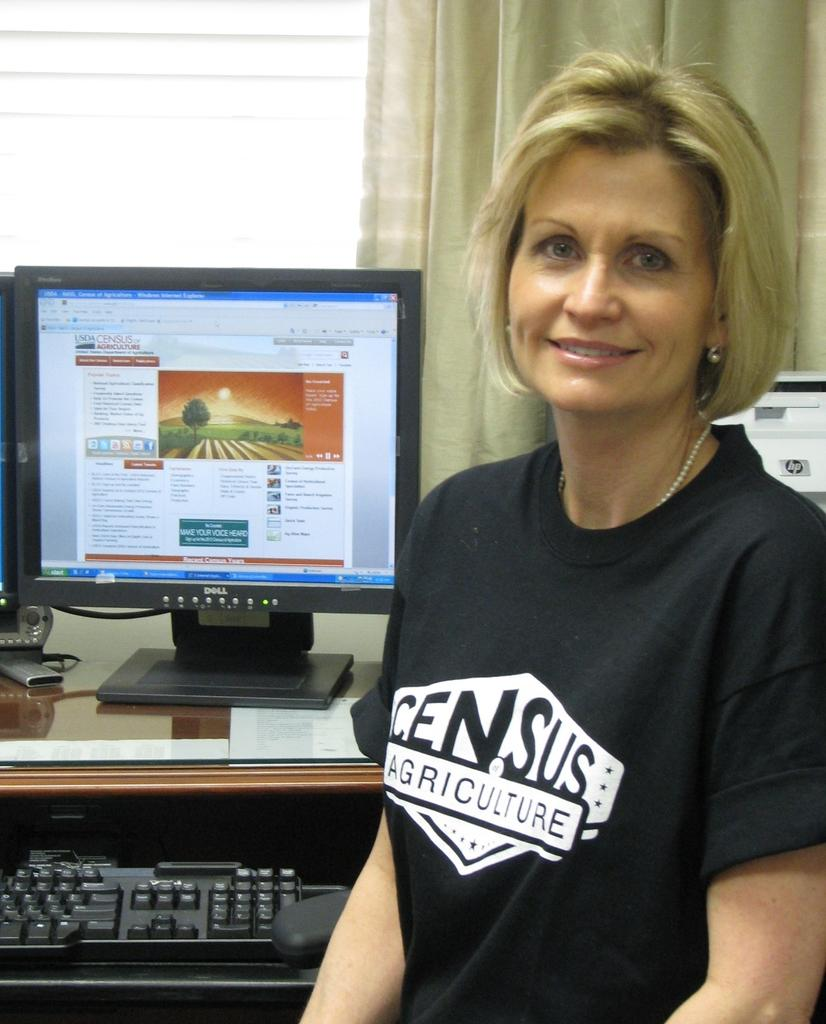<image>
Create a compact narrative representing the image presented. A lady with a Census Agriculture shirt sits in front of a computer monitor. 